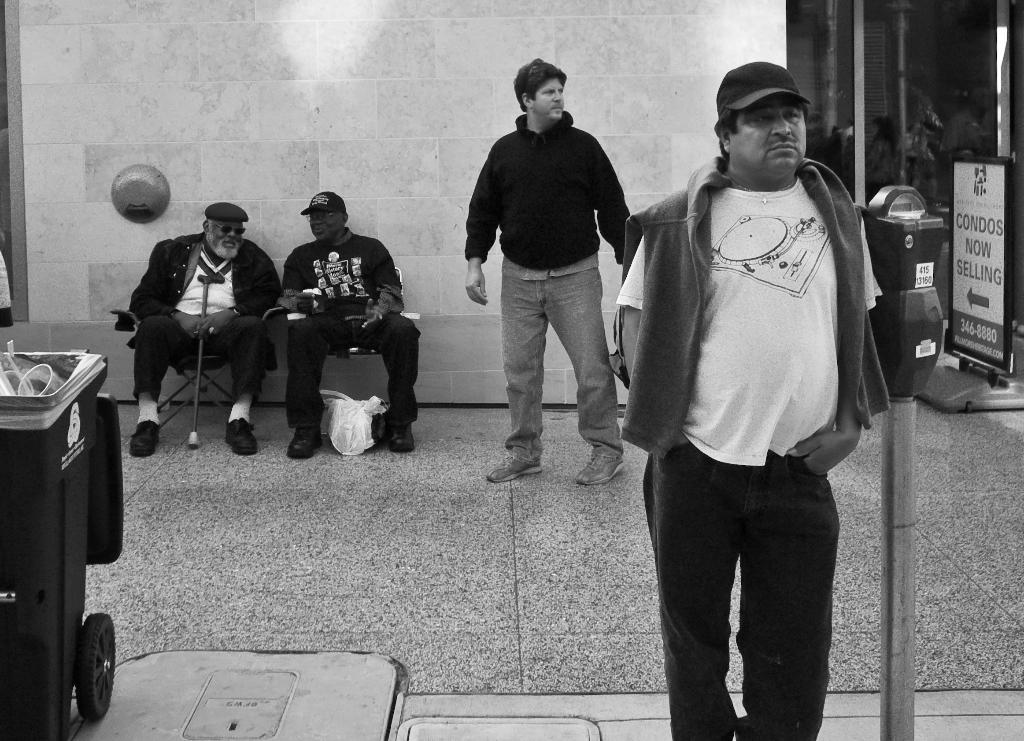How many men are present in the image? There are four men in the image, two standing and two sitting. What is the surface beneath the men's feet in the image? There is a floor visible in the image. What can be seen in the background of the image? There is a wall in the background of the image. Where is the dustbin located in the image? The dustbin is on the left side of the image. What type of rod is being used by the men in the image? There is no rod visible in the image; the men are not using any tools or objects. Can you describe the facial expressions of the men in the image? The provided facts do not mention any facial expressions of the men, so we cannot describe them. 